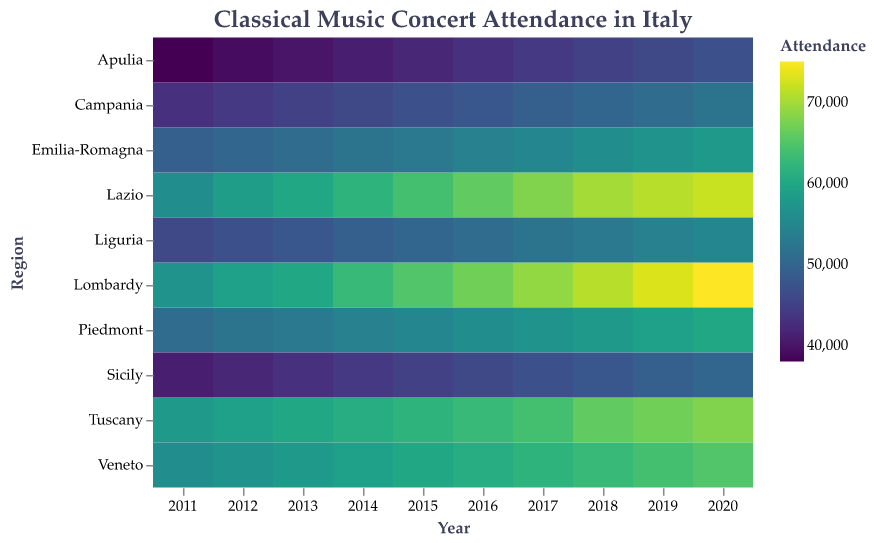What's the region with the highest concert attendance in 2020? Look at the '2020' column and identify the region with the highest attendance value. Lombardy has the highest attendance with 75,000.
Answer: Lombardy Which year had the lowest concert attendance for Sicily? Locate the row for Sicily and compare the attendance values across each year. The year 2011 has the lowest attendance with 41,000.
Answer: 2011 How did the attendance in Lazio change from 2011 to 2020? Find the attendance values for Lazio in 2011 and 2020, and calculate the difference. In 2011, it was 56,000, and in 2020, it was 72,000, so the increase is 72,000 - 56,000 = 16,000.
Answer: Increased by 16,000 What was the average attendance for Campania over the decade? Sum the attendance values for Campania across all years and divide by 10. The sum is 52,000 + 51,000 + 50,000 + 49,000 + 48,000 + 47,000 + 46,000 + 45,000 + 44,000 + 43,000 = 475,000. Thus, the average is 475,000 / 10 = 47,500.
Answer: 47,500 Which region had the most consistent attendance over the years? Identify the region with the most stable (least variation) attendance figures. Since all regions show slight increases but Lombardy and Lazio have relatively stable growth, Lombardy's attendance varies smoothly, showing consistent incremental growth every year.
Answer: Lombardy By how much did the attendance in Tuscany increase from 2014 to 2020? Look at the attendance values for Tuscany in 2014 and 2020. Subtract the 2014 attendance from the 2020 attendance. Tuscany's attendance in 2014 is 61,000 and in 2020 is 68,000, so the increase is 68,000 - 61,000 = 7,000.
Answer: 7,000 Which region had the highest attendance growth rate from 2011 to 2020? Calculate the attendance growth for each region from 2011 to 2020 and identify the region with the highest growth. Lombardy has the highest growth rate from 57,000 to 75,000.
Answer: Lombardy What's the total concert attendance in Italy for the year 2017? Sum the attendance values across all regions for the year 2017. The sum is 69,000 + 68,000 + 64,000 + 62,000 + 57,000 + 55,000 + 52,000 + 49,000 + 47,000 + 44,000 = 567,000.
Answer: 567,000 